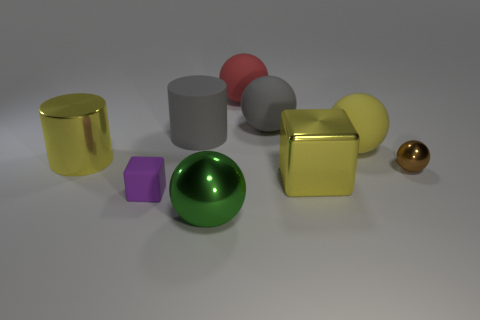What number of things are either tiny yellow balls or objects that are behind the small purple thing?
Provide a succinct answer. 7. There is a green thing that is the same material as the large yellow cylinder; what is its size?
Offer a terse response. Large. There is a metal thing that is in front of the big yellow metal thing in front of the small brown metallic thing; what is its shape?
Give a very brief answer. Sphere. How many brown things are small cylinders or tiny shiny things?
Your answer should be compact. 1. Is there a tiny matte cube behind the block to the right of the big cylinder that is behind the big yellow rubber ball?
Provide a succinct answer. No. What is the shape of the large matte object that is the same color as the shiny cylinder?
Ensure brevity in your answer.  Sphere. Is there any other thing that is made of the same material as the big yellow cylinder?
Offer a very short reply. Yes. How many big objects are either purple spheres or gray matte spheres?
Offer a terse response. 1. Do the shiny object that is to the right of the big yellow matte sphere and the tiny purple object have the same shape?
Keep it short and to the point. No. Are there fewer metallic cubes than balls?
Ensure brevity in your answer.  Yes. 